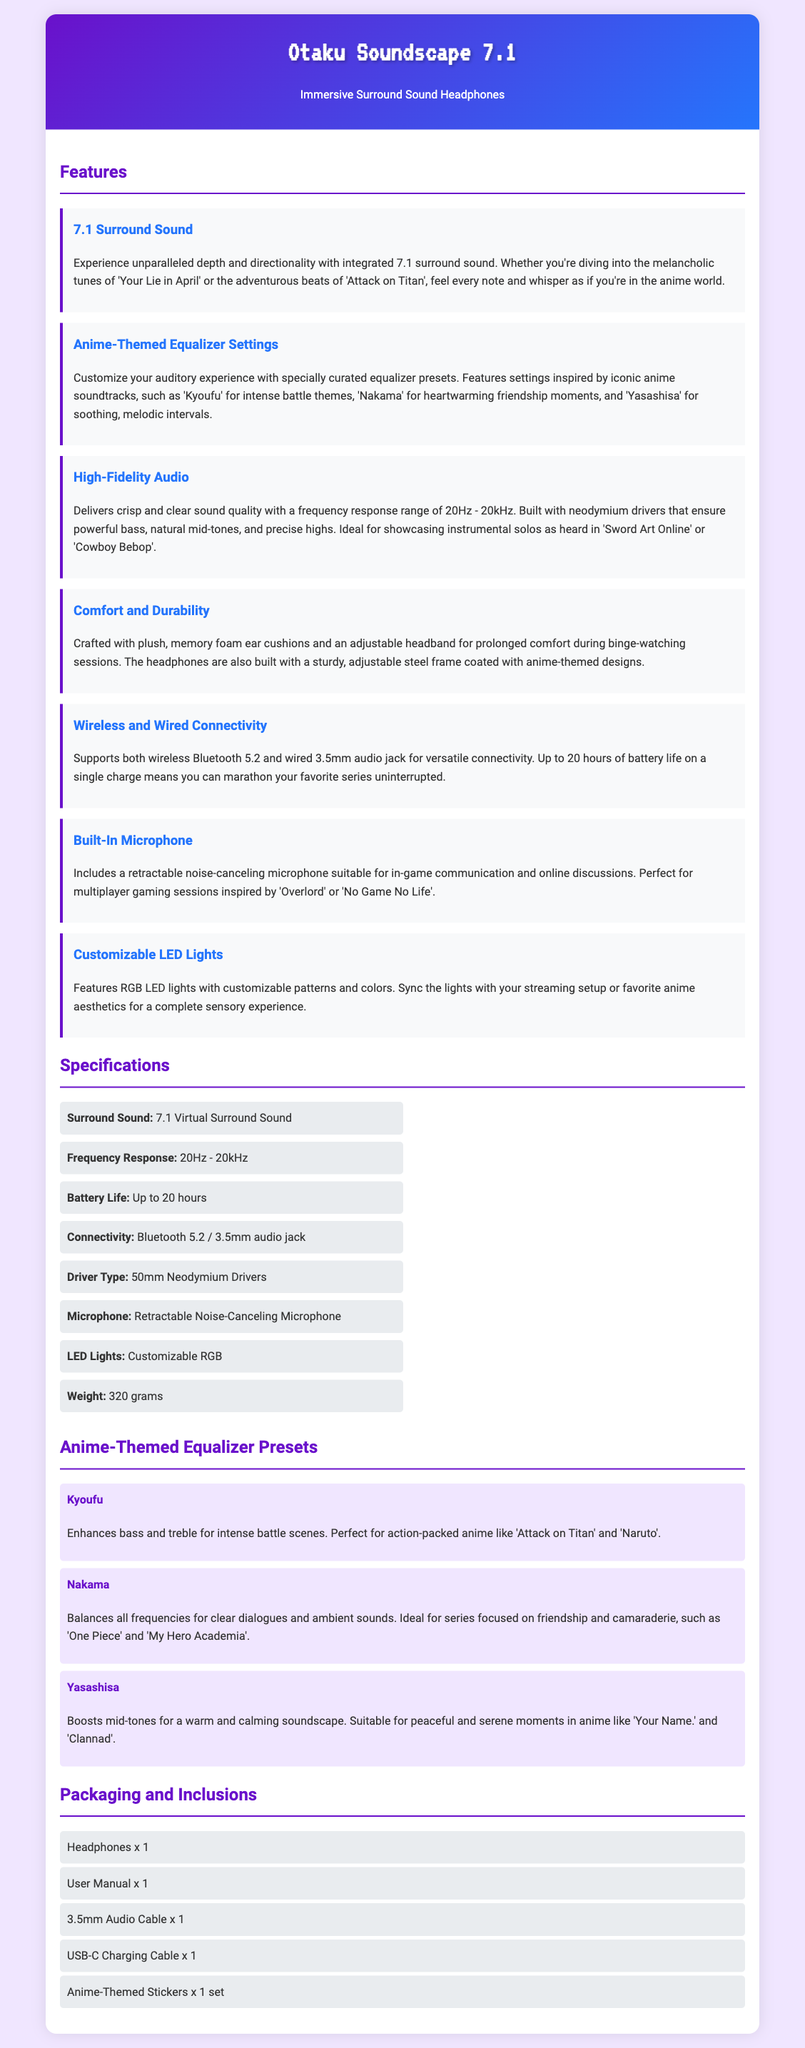what type of sound does the headphones support? The headphones support 7.1 virtual surround sound, which is mentioned in the specifications section.
Answer: 7.1 Virtual Surround Sound what is the frequency response range? The frequency response range is specified as 20Hz - 20kHz in the specifications section.
Answer: 20Hz - 20kHz how long is the battery life? The document states that the battery life is up to 20 hours on a single charge.
Answer: Up to 20 hours what theme does the 'Kyoufu' equalizer preset enhance? The 'Kyoufu' equalizer preset enhances bass and treble for intense battle scenes, as explained in the equalizer presets section.
Answer: Intense battle scenes how are the ear cushions designed for comfort? The ear cushions are described as plush, memory foam, which contributes to comfort during prolonged use.
Answer: Plush, memory foam what unique item comes with the headphones in the package? The document lists anime-themed stickers as one of the inclusions in the packaging.
Answer: Anime-Themed Stickers which connectivity options are supported by the headphones? The document mentions both wireless Bluetooth 5.2 and wired 3.5mm audio jack as connectivity options for the headphones.
Answer: Bluetooth 5.2 / 3.5mm audio jack how many presets are mentioned in the document? The document lists three presets in the anime-themed equalizer section.
Answer: Three which anime is mentioned in relation to the 'Nakama' preset? The series 'One Piece' is specifically mentioned in relation to the 'Nakama' preset for clear dialogues and ambient sounds.
Answer: One Piece 